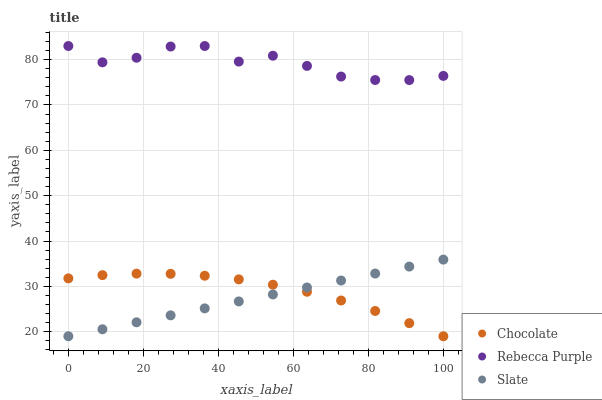Does Slate have the minimum area under the curve?
Answer yes or no. Yes. Does Rebecca Purple have the maximum area under the curve?
Answer yes or no. Yes. Does Chocolate have the minimum area under the curve?
Answer yes or no. No. Does Chocolate have the maximum area under the curve?
Answer yes or no. No. Is Slate the smoothest?
Answer yes or no. Yes. Is Rebecca Purple the roughest?
Answer yes or no. Yes. Is Chocolate the smoothest?
Answer yes or no. No. Is Chocolate the roughest?
Answer yes or no. No. Does Slate have the lowest value?
Answer yes or no. Yes. Does Rebecca Purple have the lowest value?
Answer yes or no. No. Does Rebecca Purple have the highest value?
Answer yes or no. Yes. Does Chocolate have the highest value?
Answer yes or no. No. Is Slate less than Rebecca Purple?
Answer yes or no. Yes. Is Rebecca Purple greater than Slate?
Answer yes or no. Yes. Does Slate intersect Chocolate?
Answer yes or no. Yes. Is Slate less than Chocolate?
Answer yes or no. No. Is Slate greater than Chocolate?
Answer yes or no. No. Does Slate intersect Rebecca Purple?
Answer yes or no. No. 